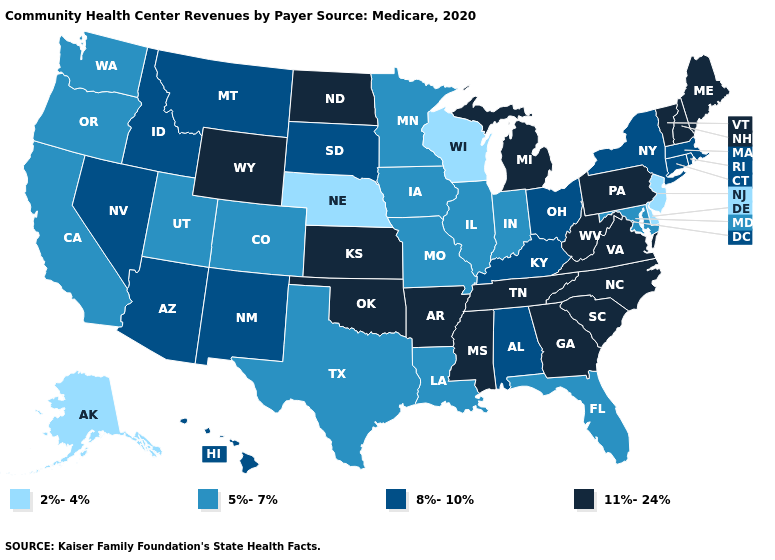What is the lowest value in states that border Idaho?
Short answer required. 5%-7%. Name the states that have a value in the range 5%-7%?
Short answer required. California, Colorado, Florida, Illinois, Indiana, Iowa, Louisiana, Maryland, Minnesota, Missouri, Oregon, Texas, Utah, Washington. What is the value of Maine?
Be succinct. 11%-24%. Name the states that have a value in the range 11%-24%?
Keep it brief. Arkansas, Georgia, Kansas, Maine, Michigan, Mississippi, New Hampshire, North Carolina, North Dakota, Oklahoma, Pennsylvania, South Carolina, Tennessee, Vermont, Virginia, West Virginia, Wyoming. Which states have the lowest value in the Northeast?
Answer briefly. New Jersey. Name the states that have a value in the range 2%-4%?
Be succinct. Alaska, Delaware, Nebraska, New Jersey, Wisconsin. Among the states that border Wyoming , which have the highest value?
Keep it brief. Idaho, Montana, South Dakota. Does Illinois have the same value as Louisiana?
Give a very brief answer. Yes. What is the value of North Carolina?
Answer briefly. 11%-24%. Does Georgia have a higher value than California?
Be succinct. Yes. What is the highest value in the USA?
Write a very short answer. 11%-24%. Which states have the lowest value in the USA?
Keep it brief. Alaska, Delaware, Nebraska, New Jersey, Wisconsin. Is the legend a continuous bar?
Keep it brief. No. Does Idaho have a higher value than Ohio?
Answer briefly. No. Does Arizona have the lowest value in the West?
Be succinct. No. 